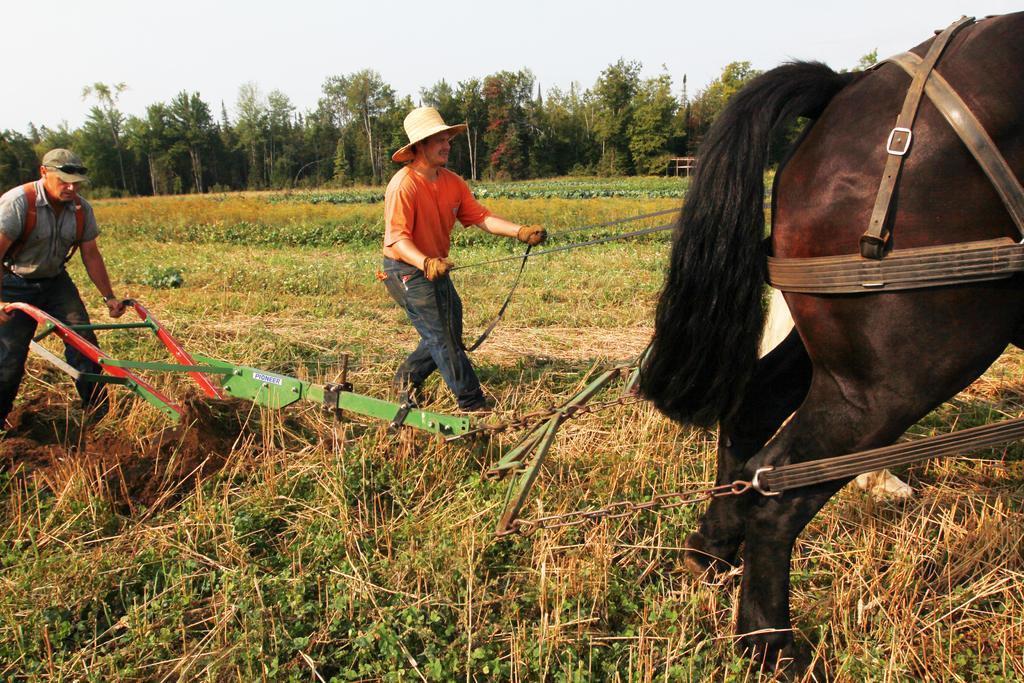Could you give a brief overview of what you see in this image? In this image there are two people farming in the agricultural field, few trees, a horse and the sky. 